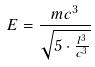Convert formula to latex. <formula><loc_0><loc_0><loc_500><loc_500>E = \frac { m c ^ { 3 } } { \sqrt { 5 \cdot \frac { l ^ { 3 } } { c ^ { 3 } } } }</formula> 